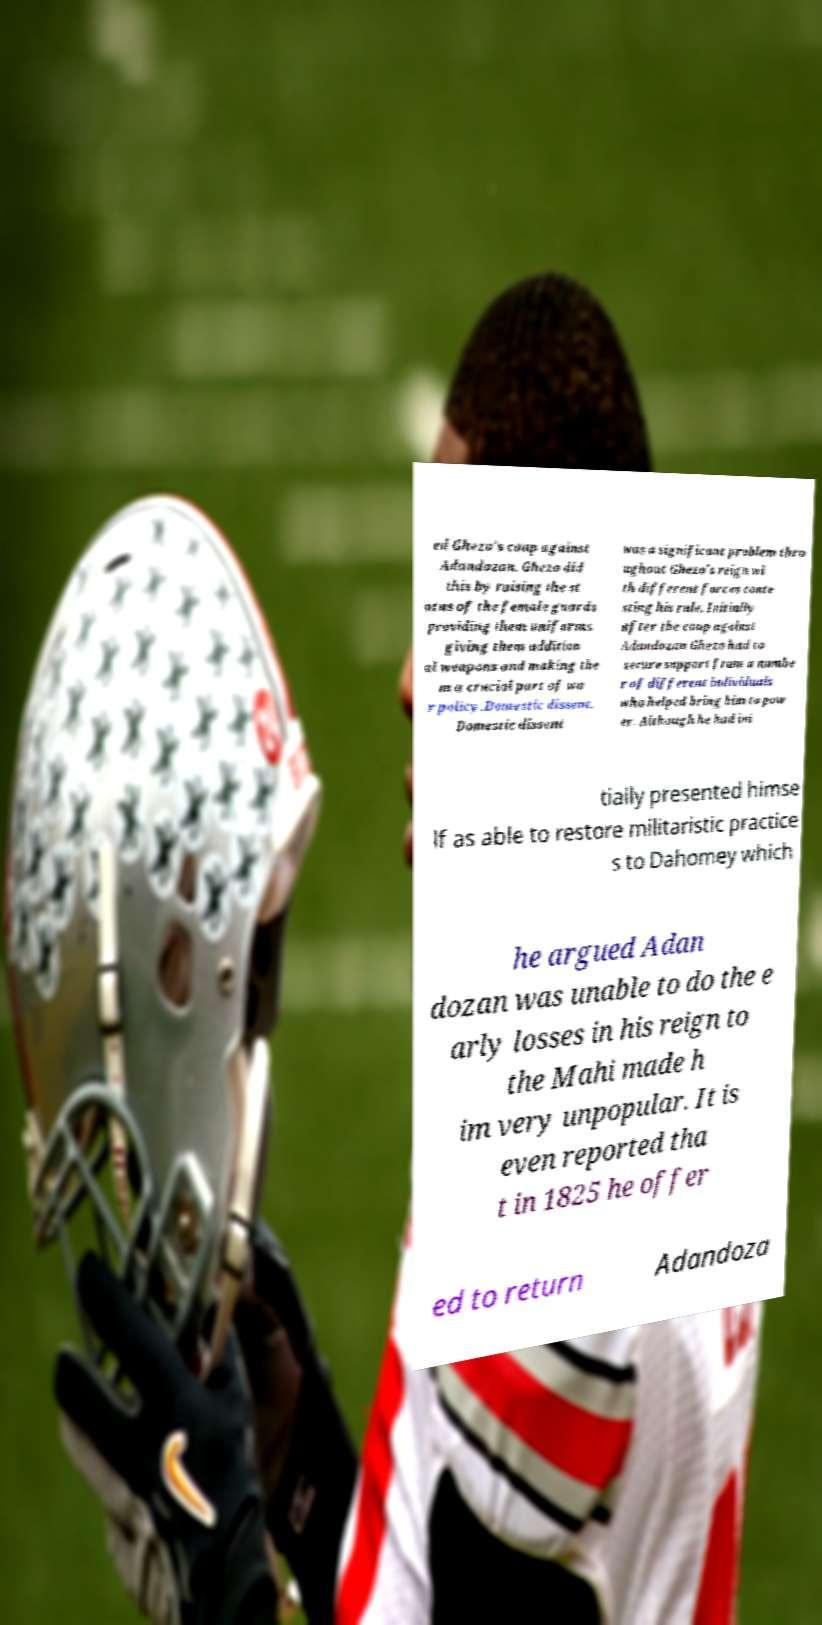What messages or text are displayed in this image? I need them in a readable, typed format. ed Ghezo's coup against Adandozan. Ghezo did this by raising the st atus of the female guards providing them uniforms giving them addition al weapons and making the m a crucial part of wa r policy.Domestic dissent. Domestic dissent was a significant problem thro ughout Ghezo's reign wi th different forces conte sting his rule. Initially after the coup against Adandozan Ghezo had to secure support from a numbe r of different individuals who helped bring him to pow er. Although he had ini tially presented himse lf as able to restore militaristic practice s to Dahomey which he argued Adan dozan was unable to do the e arly losses in his reign to the Mahi made h im very unpopular. It is even reported tha t in 1825 he offer ed to return Adandoza 